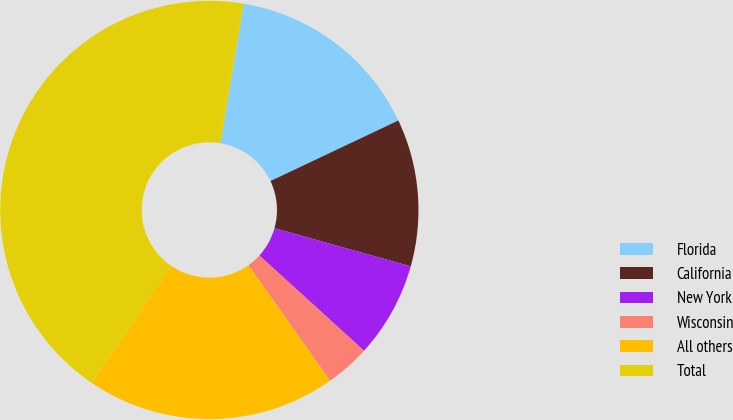Convert chart to OTSL. <chart><loc_0><loc_0><loc_500><loc_500><pie_chart><fcel>Florida<fcel>California<fcel>New York<fcel>Wisconsin<fcel>All others<fcel>Total<nl><fcel>15.34%<fcel>11.38%<fcel>7.41%<fcel>3.45%<fcel>19.31%<fcel>43.1%<nl></chart> 